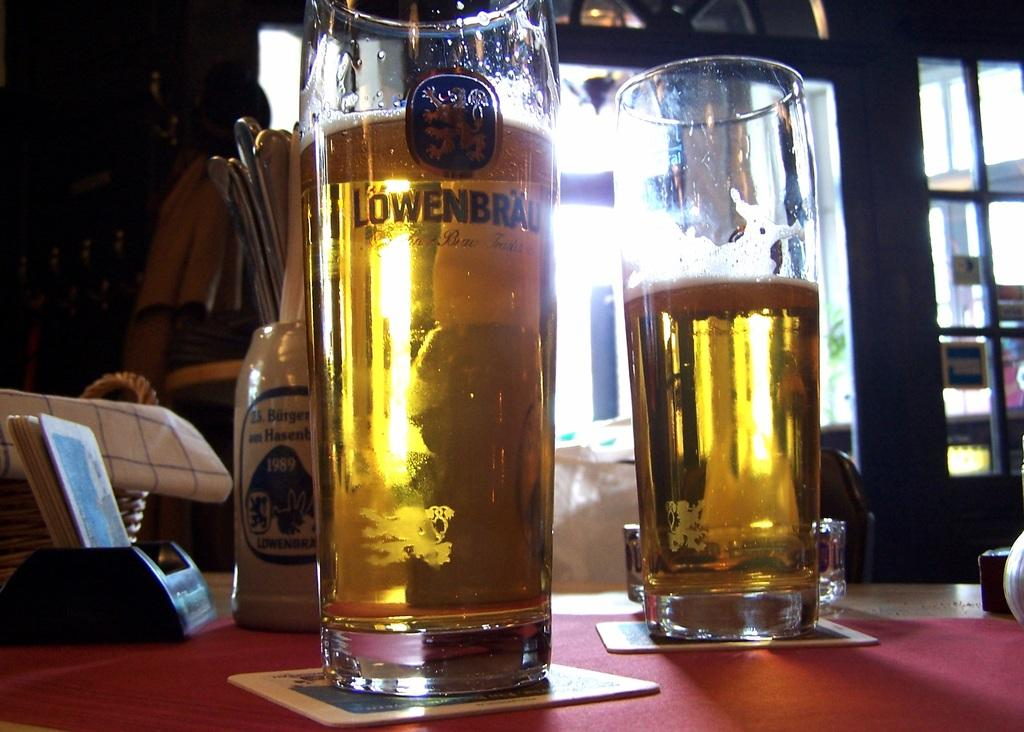<image>
Render a clear and concise summary of the photo. A large glass is full and has the Lowenbrau logo on it. 